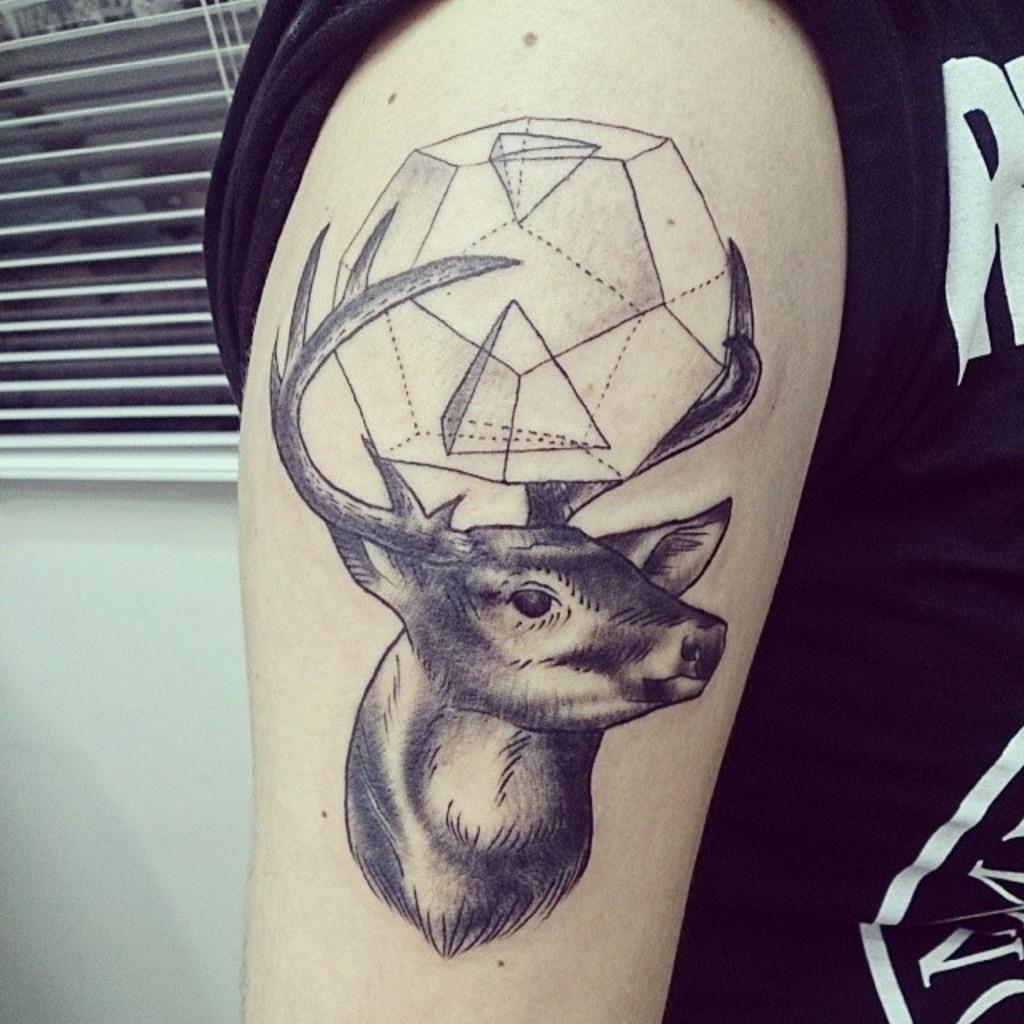What is the main subject of the image? There is a person in the image. What is the person wearing? The person is wearing a black t-shirt. Can you describe any distinguishing features of the person? The person has a tattoo on their hand. What can be seen in the background of the image? There is a wall in the background of the image. What is a notable feature of the wall? The wall has window shutters. What type of poison is the person holding in the image? There is no poison present in the image; the person is not holding any such substance. Is there a volleyball game taking place in the image? There is no volleyball game or any reference to volleyball in the image. 